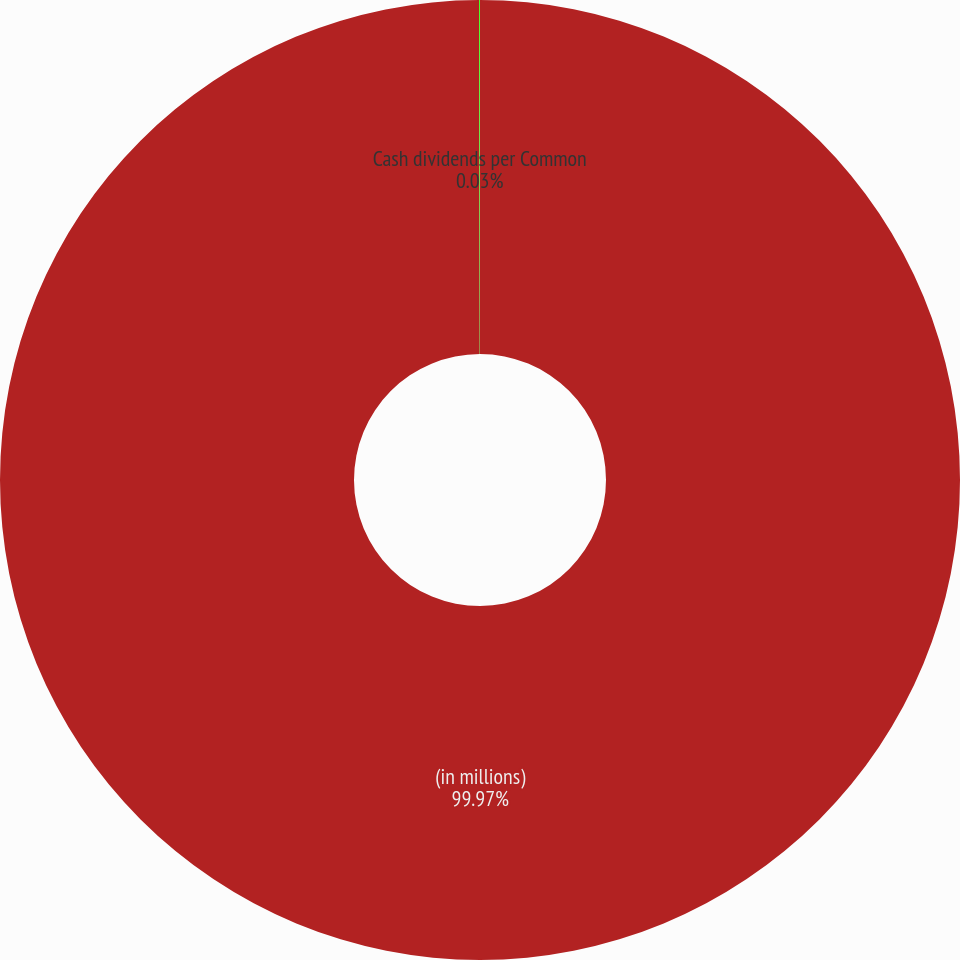Convert chart to OTSL. <chart><loc_0><loc_0><loc_500><loc_500><pie_chart><fcel>(in millions)<fcel>Cash dividends per Common<nl><fcel>99.97%<fcel>0.03%<nl></chart> 